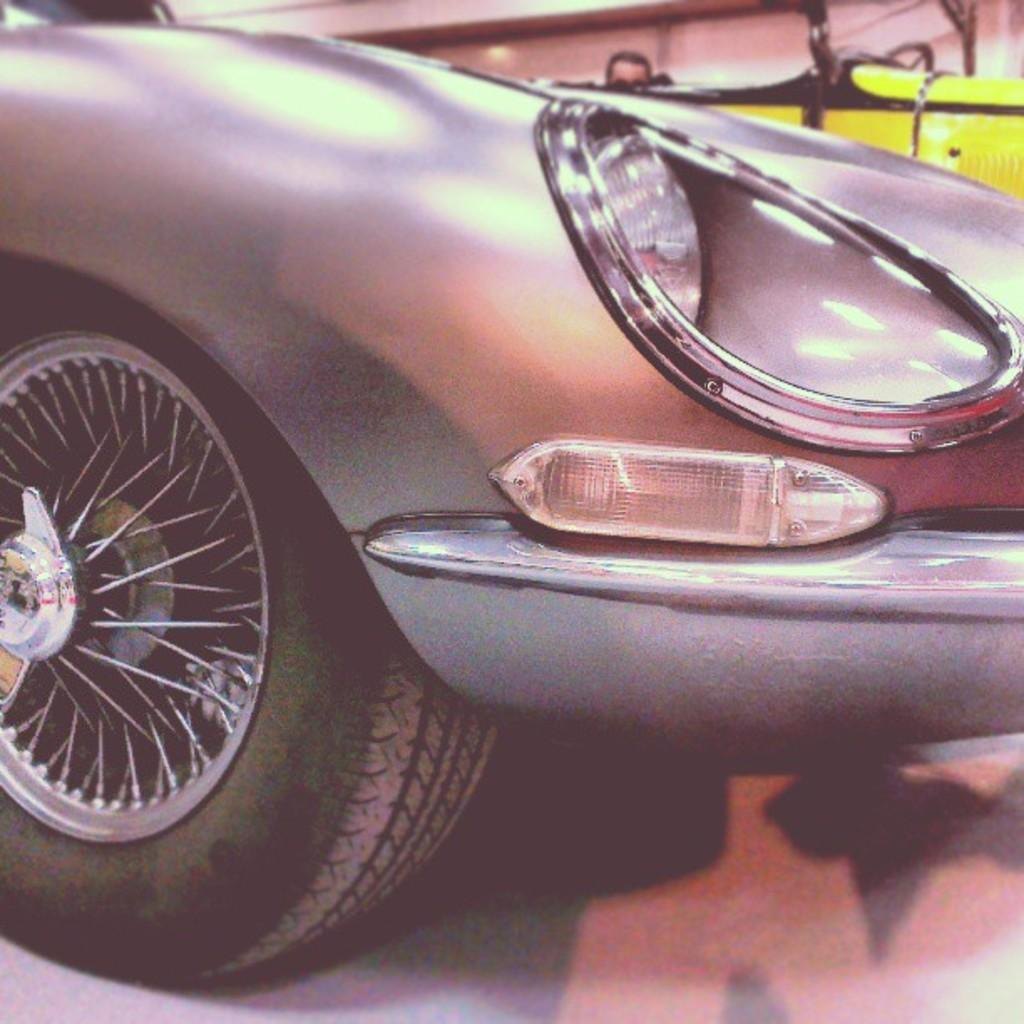What type of vehicle is in the image? There is a car in the image. What color is the car? The car is silver in color. What can be seen in the background of the image? There is a yellow object in the background of the image. Can you identify any human presence in the image? Yes, a person's head is visible in the image. Where is the cat sitting in the image? There is no cat present in the image. What type of hill can be seen in the background of the image? There is no hill visible in the image; only a yellow object is present in the background. 